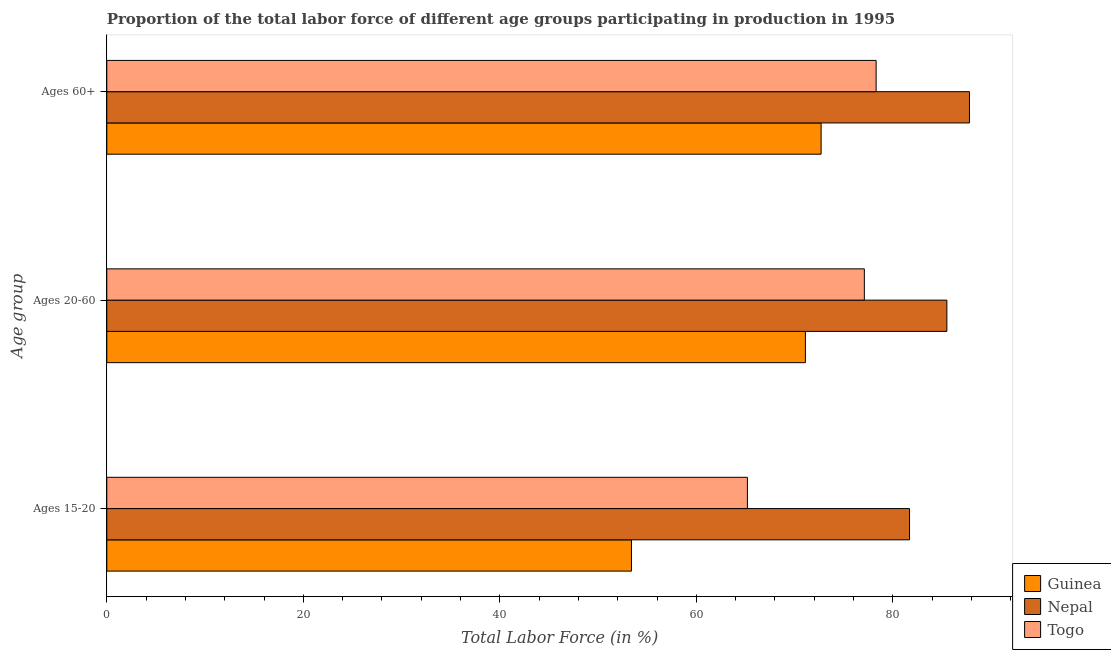How many groups of bars are there?
Offer a very short reply. 3. Are the number of bars on each tick of the Y-axis equal?
Ensure brevity in your answer.  Yes. What is the label of the 2nd group of bars from the top?
Offer a very short reply. Ages 20-60. What is the percentage of labor force above age 60 in Nepal?
Give a very brief answer. 87.8. Across all countries, what is the maximum percentage of labor force within the age group 15-20?
Your answer should be compact. 81.7. Across all countries, what is the minimum percentage of labor force within the age group 15-20?
Your answer should be very brief. 53.4. In which country was the percentage of labor force above age 60 maximum?
Offer a very short reply. Nepal. In which country was the percentage of labor force above age 60 minimum?
Offer a terse response. Guinea. What is the total percentage of labor force within the age group 15-20 in the graph?
Your answer should be very brief. 200.3. What is the difference between the percentage of labor force above age 60 in Togo and that in Nepal?
Provide a succinct answer. -9.5. What is the difference between the percentage of labor force above age 60 in Nepal and the percentage of labor force within the age group 15-20 in Guinea?
Provide a succinct answer. 34.4. What is the average percentage of labor force within the age group 15-20 per country?
Offer a very short reply. 66.77. What is the difference between the percentage of labor force within the age group 20-60 and percentage of labor force above age 60 in Guinea?
Offer a very short reply. -1.6. What is the ratio of the percentage of labor force within the age group 15-20 in Togo to that in Nepal?
Keep it short and to the point. 0.8. What is the difference between the highest and the second highest percentage of labor force above age 60?
Ensure brevity in your answer.  9.5. What is the difference between the highest and the lowest percentage of labor force within the age group 15-20?
Give a very brief answer. 28.3. In how many countries, is the percentage of labor force above age 60 greater than the average percentage of labor force above age 60 taken over all countries?
Your answer should be very brief. 1. What does the 1st bar from the top in Ages 20-60 represents?
Provide a short and direct response. Togo. What does the 2nd bar from the bottom in Ages 60+ represents?
Ensure brevity in your answer.  Nepal. Is it the case that in every country, the sum of the percentage of labor force within the age group 15-20 and percentage of labor force within the age group 20-60 is greater than the percentage of labor force above age 60?
Ensure brevity in your answer.  Yes. Are all the bars in the graph horizontal?
Offer a very short reply. Yes. How many countries are there in the graph?
Your answer should be very brief. 3. What is the difference between two consecutive major ticks on the X-axis?
Ensure brevity in your answer.  20. Where does the legend appear in the graph?
Your answer should be very brief. Bottom right. What is the title of the graph?
Ensure brevity in your answer.  Proportion of the total labor force of different age groups participating in production in 1995. Does "Papua New Guinea" appear as one of the legend labels in the graph?
Make the answer very short. No. What is the label or title of the Y-axis?
Your answer should be very brief. Age group. What is the Total Labor Force (in %) of Guinea in Ages 15-20?
Your answer should be very brief. 53.4. What is the Total Labor Force (in %) of Nepal in Ages 15-20?
Offer a very short reply. 81.7. What is the Total Labor Force (in %) of Togo in Ages 15-20?
Offer a very short reply. 65.2. What is the Total Labor Force (in %) in Guinea in Ages 20-60?
Offer a terse response. 71.1. What is the Total Labor Force (in %) in Nepal in Ages 20-60?
Provide a succinct answer. 85.5. What is the Total Labor Force (in %) of Togo in Ages 20-60?
Keep it short and to the point. 77.1. What is the Total Labor Force (in %) in Guinea in Ages 60+?
Your answer should be compact. 72.7. What is the Total Labor Force (in %) in Nepal in Ages 60+?
Your answer should be compact. 87.8. What is the Total Labor Force (in %) of Togo in Ages 60+?
Provide a succinct answer. 78.3. Across all Age group, what is the maximum Total Labor Force (in %) of Guinea?
Provide a succinct answer. 72.7. Across all Age group, what is the maximum Total Labor Force (in %) of Nepal?
Your response must be concise. 87.8. Across all Age group, what is the maximum Total Labor Force (in %) of Togo?
Ensure brevity in your answer.  78.3. Across all Age group, what is the minimum Total Labor Force (in %) of Guinea?
Your answer should be very brief. 53.4. Across all Age group, what is the minimum Total Labor Force (in %) of Nepal?
Offer a terse response. 81.7. Across all Age group, what is the minimum Total Labor Force (in %) in Togo?
Ensure brevity in your answer.  65.2. What is the total Total Labor Force (in %) in Guinea in the graph?
Offer a very short reply. 197.2. What is the total Total Labor Force (in %) in Nepal in the graph?
Make the answer very short. 255. What is the total Total Labor Force (in %) in Togo in the graph?
Provide a succinct answer. 220.6. What is the difference between the Total Labor Force (in %) of Guinea in Ages 15-20 and that in Ages 20-60?
Offer a terse response. -17.7. What is the difference between the Total Labor Force (in %) of Guinea in Ages 15-20 and that in Ages 60+?
Provide a succinct answer. -19.3. What is the difference between the Total Labor Force (in %) in Nepal in Ages 15-20 and that in Ages 60+?
Your answer should be very brief. -6.1. What is the difference between the Total Labor Force (in %) of Guinea in Ages 15-20 and the Total Labor Force (in %) of Nepal in Ages 20-60?
Give a very brief answer. -32.1. What is the difference between the Total Labor Force (in %) of Guinea in Ages 15-20 and the Total Labor Force (in %) of Togo in Ages 20-60?
Make the answer very short. -23.7. What is the difference between the Total Labor Force (in %) in Nepal in Ages 15-20 and the Total Labor Force (in %) in Togo in Ages 20-60?
Provide a succinct answer. 4.6. What is the difference between the Total Labor Force (in %) of Guinea in Ages 15-20 and the Total Labor Force (in %) of Nepal in Ages 60+?
Keep it short and to the point. -34.4. What is the difference between the Total Labor Force (in %) of Guinea in Ages 15-20 and the Total Labor Force (in %) of Togo in Ages 60+?
Offer a terse response. -24.9. What is the difference between the Total Labor Force (in %) in Guinea in Ages 20-60 and the Total Labor Force (in %) in Nepal in Ages 60+?
Make the answer very short. -16.7. What is the difference between the Total Labor Force (in %) in Guinea in Ages 20-60 and the Total Labor Force (in %) in Togo in Ages 60+?
Your answer should be compact. -7.2. What is the average Total Labor Force (in %) of Guinea per Age group?
Keep it short and to the point. 65.73. What is the average Total Labor Force (in %) of Togo per Age group?
Provide a short and direct response. 73.53. What is the difference between the Total Labor Force (in %) in Guinea and Total Labor Force (in %) in Nepal in Ages 15-20?
Keep it short and to the point. -28.3. What is the difference between the Total Labor Force (in %) of Guinea and Total Labor Force (in %) of Nepal in Ages 20-60?
Your answer should be compact. -14.4. What is the difference between the Total Labor Force (in %) of Guinea and Total Labor Force (in %) of Nepal in Ages 60+?
Give a very brief answer. -15.1. What is the ratio of the Total Labor Force (in %) in Guinea in Ages 15-20 to that in Ages 20-60?
Provide a succinct answer. 0.75. What is the ratio of the Total Labor Force (in %) in Nepal in Ages 15-20 to that in Ages 20-60?
Your answer should be very brief. 0.96. What is the ratio of the Total Labor Force (in %) in Togo in Ages 15-20 to that in Ages 20-60?
Offer a terse response. 0.85. What is the ratio of the Total Labor Force (in %) of Guinea in Ages 15-20 to that in Ages 60+?
Offer a very short reply. 0.73. What is the ratio of the Total Labor Force (in %) in Nepal in Ages 15-20 to that in Ages 60+?
Make the answer very short. 0.93. What is the ratio of the Total Labor Force (in %) of Togo in Ages 15-20 to that in Ages 60+?
Ensure brevity in your answer.  0.83. What is the ratio of the Total Labor Force (in %) of Guinea in Ages 20-60 to that in Ages 60+?
Keep it short and to the point. 0.98. What is the ratio of the Total Labor Force (in %) in Nepal in Ages 20-60 to that in Ages 60+?
Give a very brief answer. 0.97. What is the ratio of the Total Labor Force (in %) of Togo in Ages 20-60 to that in Ages 60+?
Offer a terse response. 0.98. What is the difference between the highest and the lowest Total Labor Force (in %) of Guinea?
Your response must be concise. 19.3. 